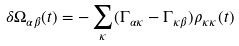<formula> <loc_0><loc_0><loc_500><loc_500>\delta \Omega _ { \alpha \beta } ( t ) = - \sum _ { \kappa } ( \Gamma _ { \alpha \kappa } - \Gamma _ { \kappa \beta } ) \rho _ { \kappa \kappa } ( t )</formula> 